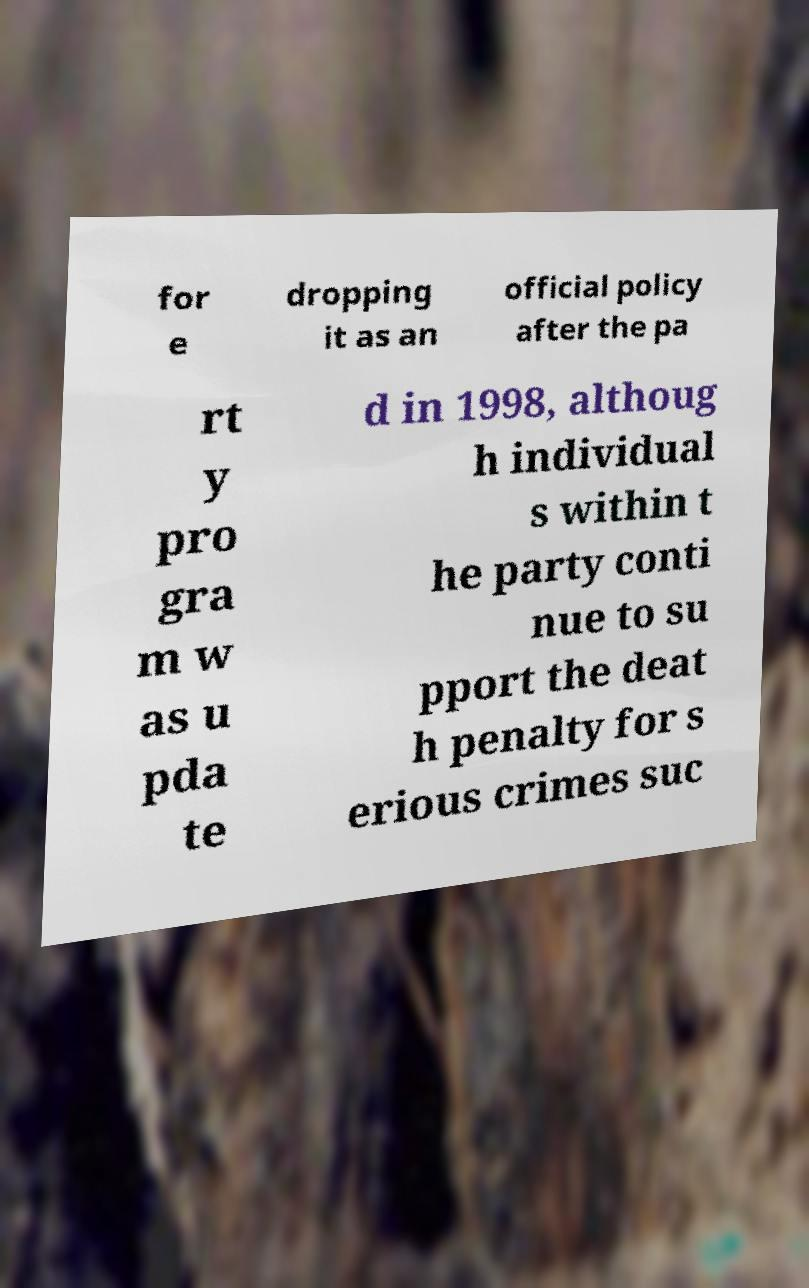Could you extract and type out the text from this image? for e dropping it as an official policy after the pa rt y pro gra m w as u pda te d in 1998, althoug h individual s within t he party conti nue to su pport the deat h penalty for s erious crimes suc 